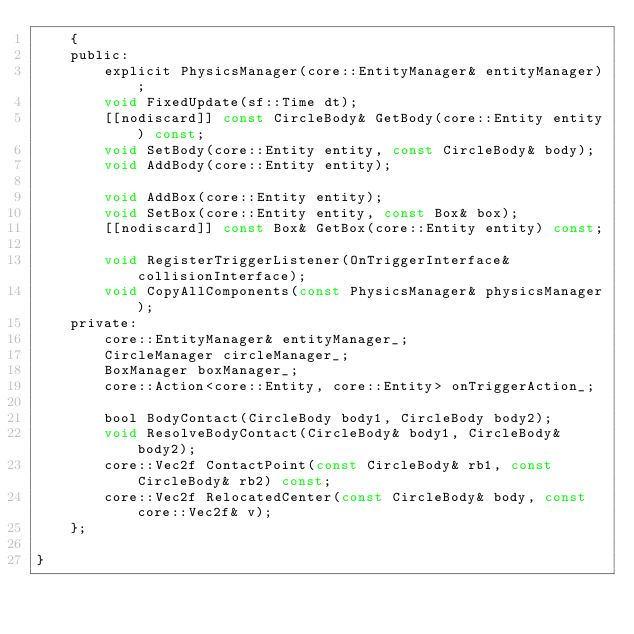Convert code to text. <code><loc_0><loc_0><loc_500><loc_500><_C_>    {
    public:
        explicit PhysicsManager(core::EntityManager& entityManager);
        void FixedUpdate(sf::Time dt);
        [[nodiscard]] const CircleBody& GetBody(core::Entity entity) const;
        void SetBody(core::Entity entity, const CircleBody& body);
        void AddBody(core::Entity entity);

        void AddBox(core::Entity entity);
        void SetBox(core::Entity entity, const Box& box);
        [[nodiscard]] const Box& GetBox(core::Entity entity) const;

        void RegisterTriggerListener(OnTriggerInterface& collisionInterface);
        void CopyAllComponents(const PhysicsManager& physicsManager);
    private:
        core::EntityManager& entityManager_;
        CircleManager circleManager_;
        BoxManager boxManager_;
        core::Action<core::Entity, core::Entity> onTriggerAction_;

        bool BodyContact(CircleBody body1, CircleBody body2);
        void ResolveBodyContact(CircleBody& body1, CircleBody& body2);
        core::Vec2f ContactPoint(const CircleBody& rb1, const CircleBody& rb2) const;
        core::Vec2f RelocatedCenter(const CircleBody& body, const core::Vec2f& v);
    };

}
</code> 